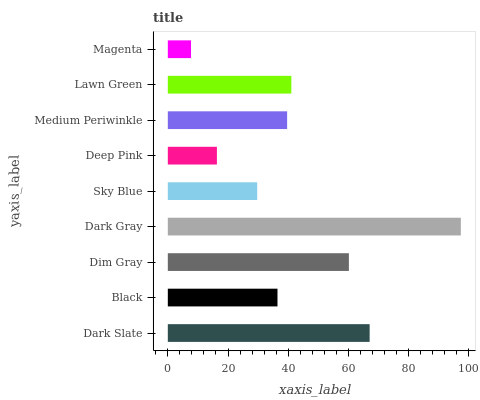Is Magenta the minimum?
Answer yes or no. Yes. Is Dark Gray the maximum?
Answer yes or no. Yes. Is Black the minimum?
Answer yes or no. No. Is Black the maximum?
Answer yes or no. No. Is Dark Slate greater than Black?
Answer yes or no. Yes. Is Black less than Dark Slate?
Answer yes or no. Yes. Is Black greater than Dark Slate?
Answer yes or no. No. Is Dark Slate less than Black?
Answer yes or no. No. Is Medium Periwinkle the high median?
Answer yes or no. Yes. Is Medium Periwinkle the low median?
Answer yes or no. Yes. Is Dark Slate the high median?
Answer yes or no. No. Is Magenta the low median?
Answer yes or no. No. 